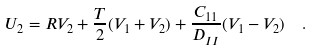<formula> <loc_0><loc_0><loc_500><loc_500>U _ { 2 } = R V _ { 2 } + \frac { T } { 2 } ( V _ { 1 } + V _ { 2 } ) + \frac { C _ { 1 1 } } { D _ { I I } } ( V _ { 1 } - V _ { 2 } ) \ \ .</formula> 